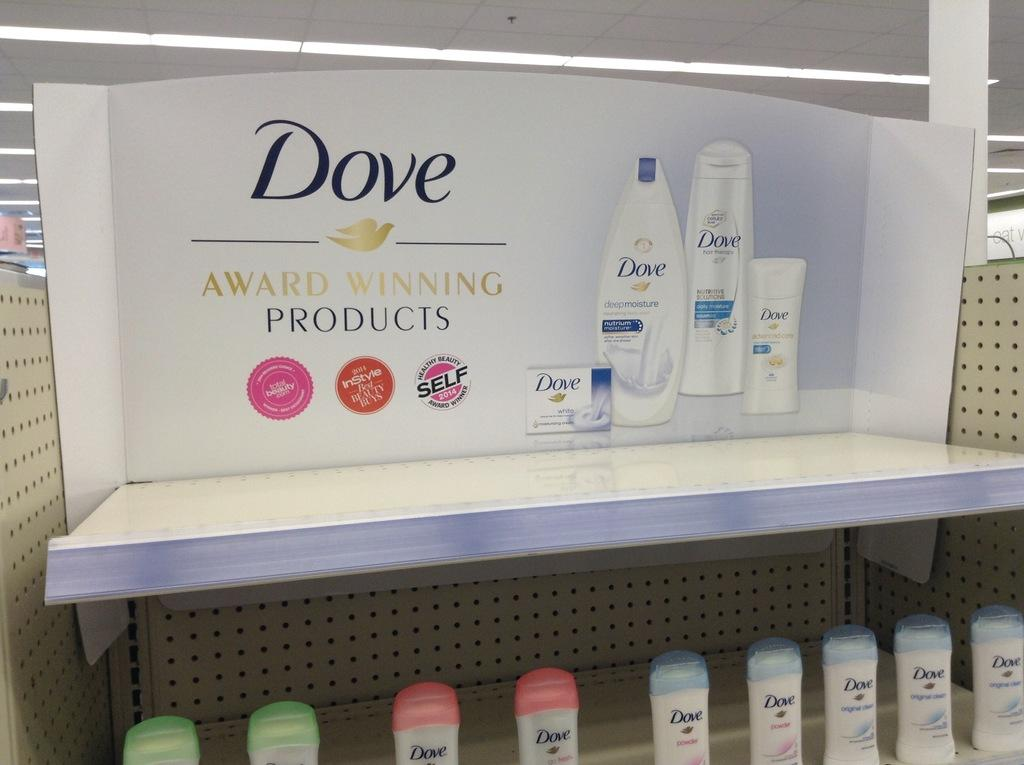<image>
Share a concise interpretation of the image provided. Dove is being advertised as selling award winning products. 